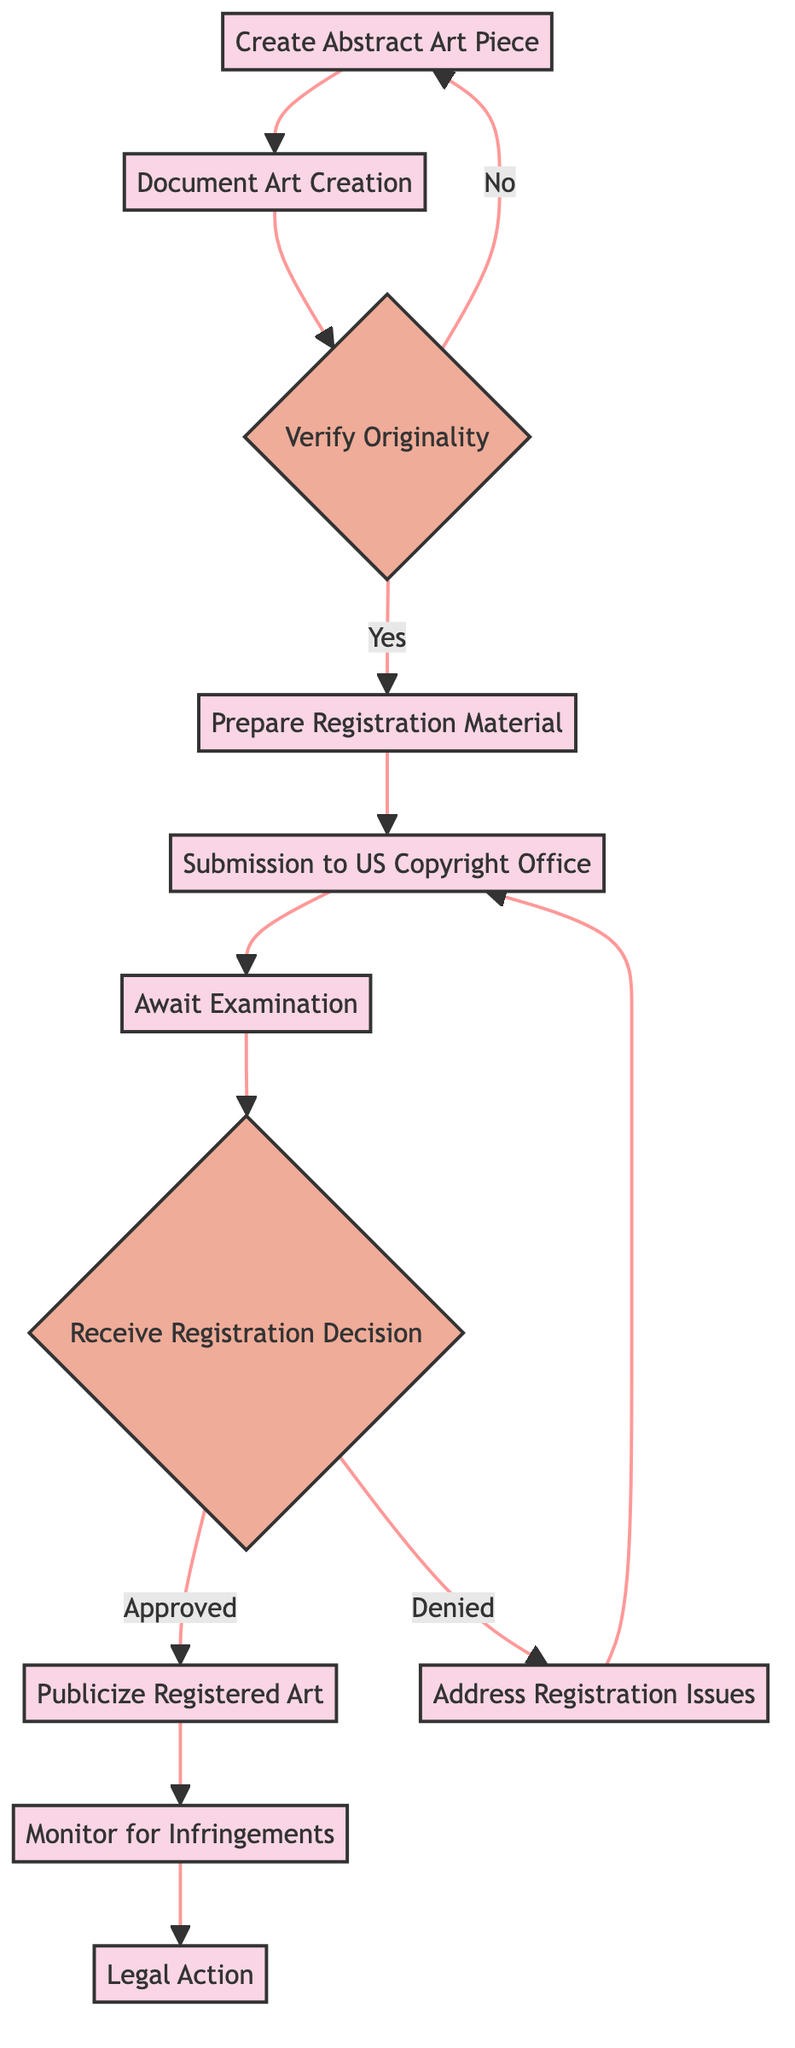What is the first step in the workflow? The first step in the workflow, according to the diagram, is "Create Abstract Art Piece". This is represented as the initial node in the flowchart.
Answer: Create Abstract Art Piece How many decision nodes are present in the diagram? The diagram contains three decision nodes: "Verify Originality" and "Receive Registration Decision". Count each decision shape in the flowchart to arrive at the answer.
Answer: 2 What happens if the originality check fails? If the originality check fails, the process loops back to the first step, which is "Create Abstract Art Piece". This is indicated by the flow directed from "Verify Originality" with a "No" condition to "Create Abstract Art Piece".
Answer: Create Abstract Art Piece Which step requires waiting for examination? The step "Await Examination" requires waiting for examination by the Copyright Office. This is explicitly stated in the description of that node.
Answer: Await Examination What is the last action taken in the process? The last action in the process is "Legal Action". This step is the final node in the flow after monitoring for infringements.
Answer: Legal Action What documentation is necessary before submitting to the US Copyright Office? The required documentation includes high-quality images of the art, descriptions, and proof of creation date. This information is listed in the "Prepare Registration Material" step.
Answer: High-quality images, descriptions, proof of creation date If registration is denied, what is the next step? If the registration is denied, the next step is "Address Registration Issues", which is specified as the action taken after receiving a "No" from the "Receive Registration Decision" node.
Answer: Address Registration Issues How many total steps are there in the workflow? The diagram features a total of 11 steps, which can be counted directly from the list of steps provided in the data.
Answer: 11 What step comes after publicizing registered art? The step that comes after publicizing registered art is "Monitor for Infringements". The flow from "Publicize Registered Art" points directly to this next step in the sequence.
Answer: Monitor for Infringements 